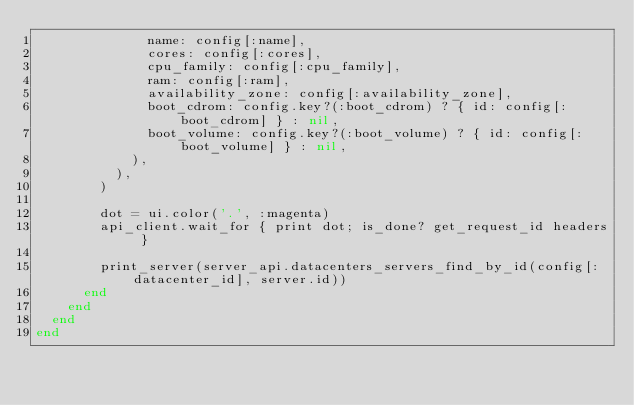<code> <loc_0><loc_0><loc_500><loc_500><_Ruby_>              name: config[:name],
              cores: config[:cores],
              cpu_family: config[:cpu_family],
              ram: config[:ram],
              availability_zone: config[:availability_zone],
              boot_cdrom: config.key?(:boot_cdrom) ? { id: config[:boot_cdrom] } : nil,
              boot_volume: config.key?(:boot_volume) ? { id: config[:boot_volume] } : nil,
            ),
          ),
        )

        dot = ui.color('.', :magenta)
        api_client.wait_for { print dot; is_done? get_request_id headers }

        print_server(server_api.datacenters_servers_find_by_id(config[:datacenter_id], server.id))
      end
    end
  end
end
</code> 